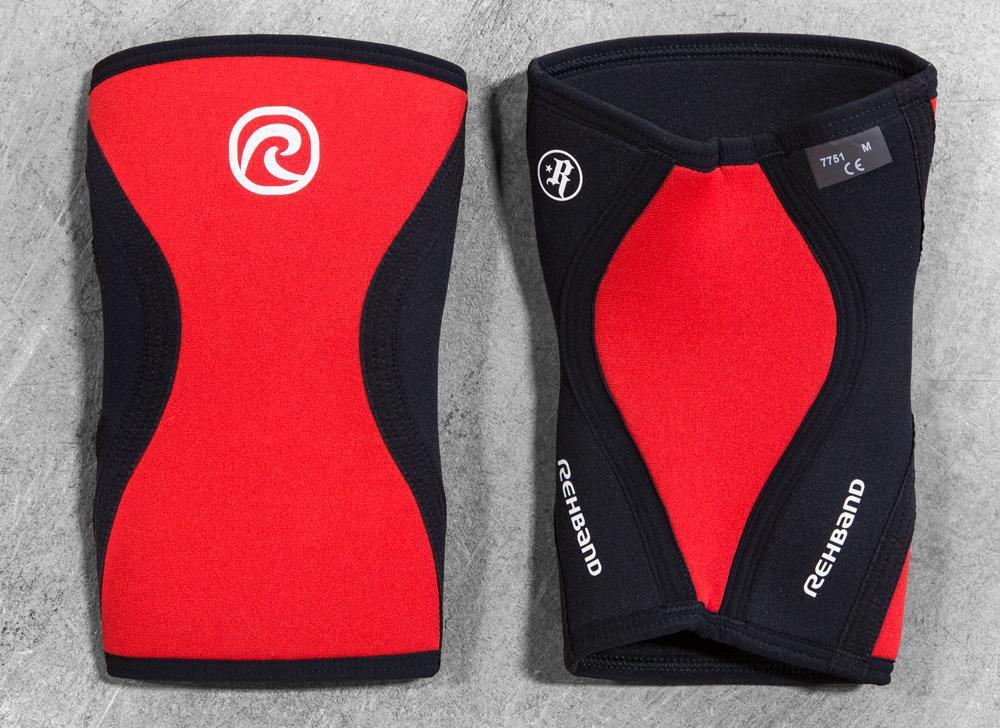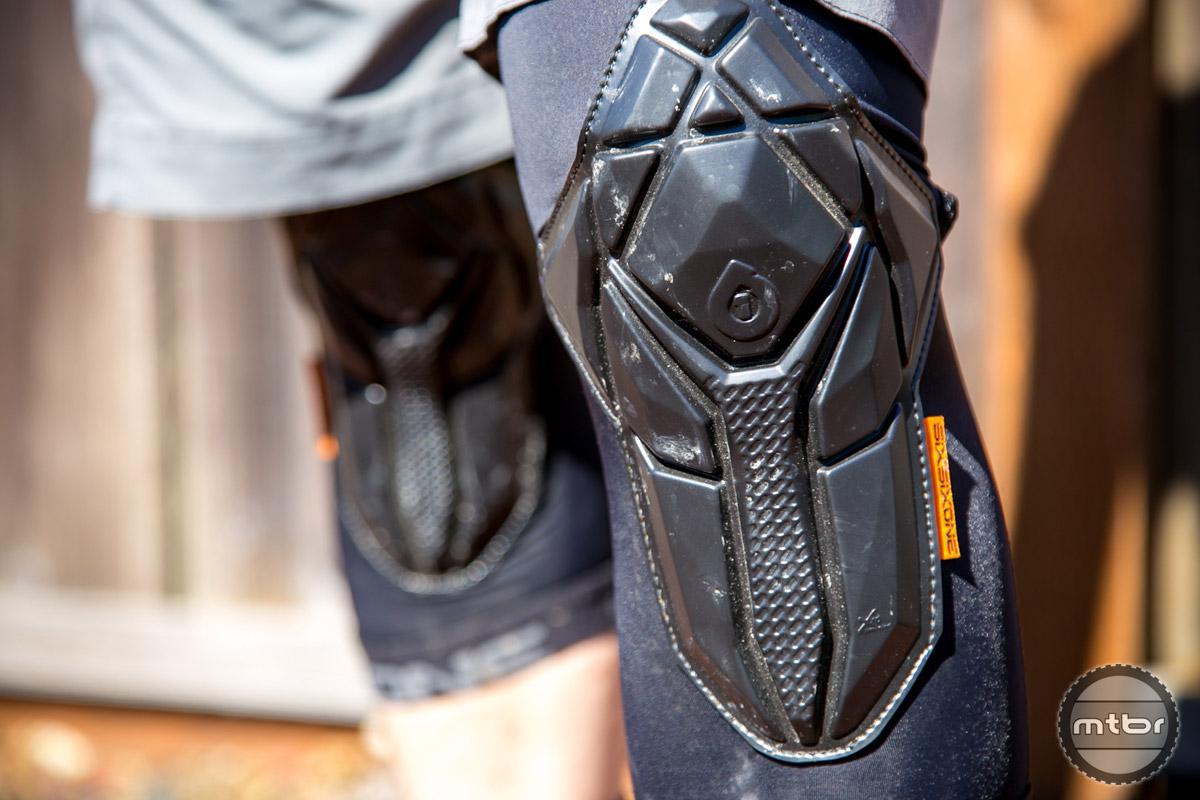The first image is the image on the left, the second image is the image on the right. For the images shown, is this caption "No one is wearing the pads in the image on the right." true? Answer yes or no. No. 